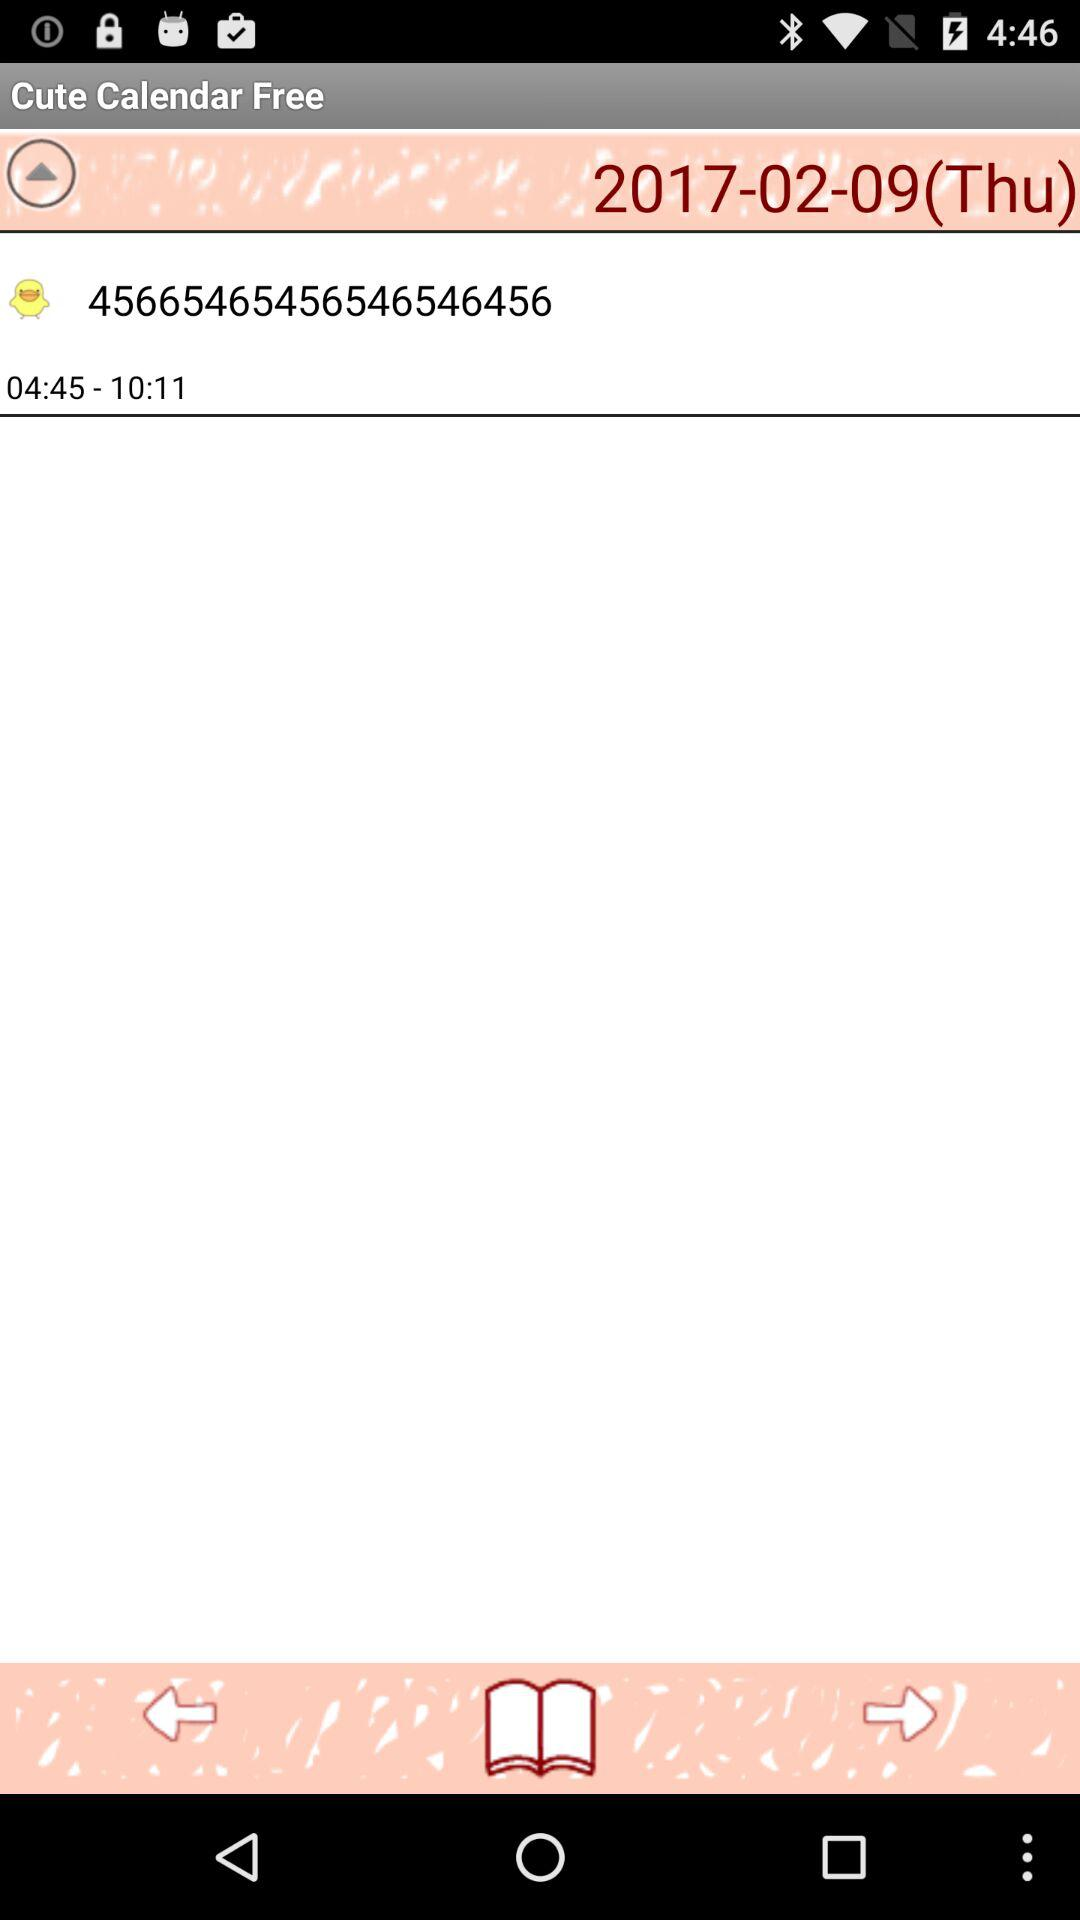What is the mentioned number? The mentioned number is 45665465456546546456. 